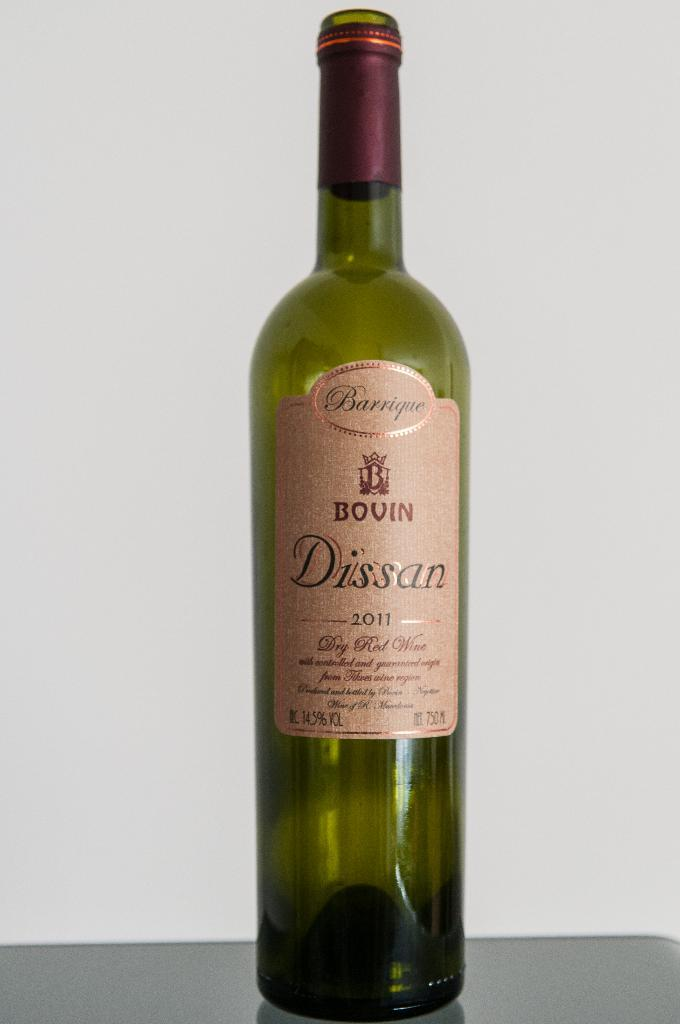<image>
Create a compact narrative representing the image presented. A bottle of Bovin Dissan, from 2011, has a green colored bottle. 